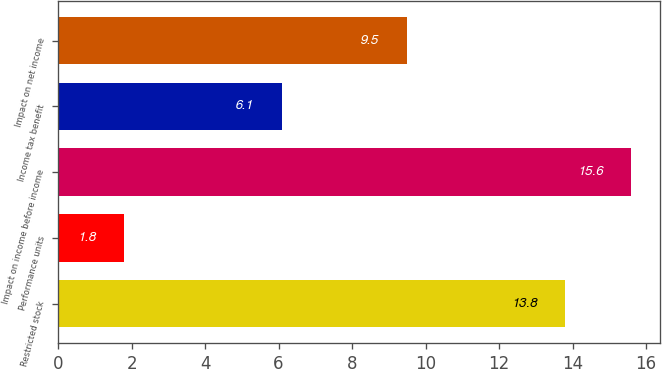Convert chart. <chart><loc_0><loc_0><loc_500><loc_500><bar_chart><fcel>Restricted stock<fcel>Performance units<fcel>Impact on income before income<fcel>Income tax benefit<fcel>Impact on net income<nl><fcel>13.8<fcel>1.8<fcel>15.6<fcel>6.1<fcel>9.5<nl></chart> 